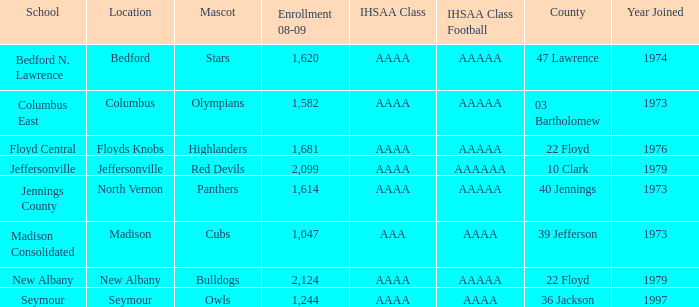What's the IHSAA Class when the school is Seymour? AAAA. 